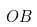Convert formula to latex. <formula><loc_0><loc_0><loc_500><loc_500>O B</formula> 